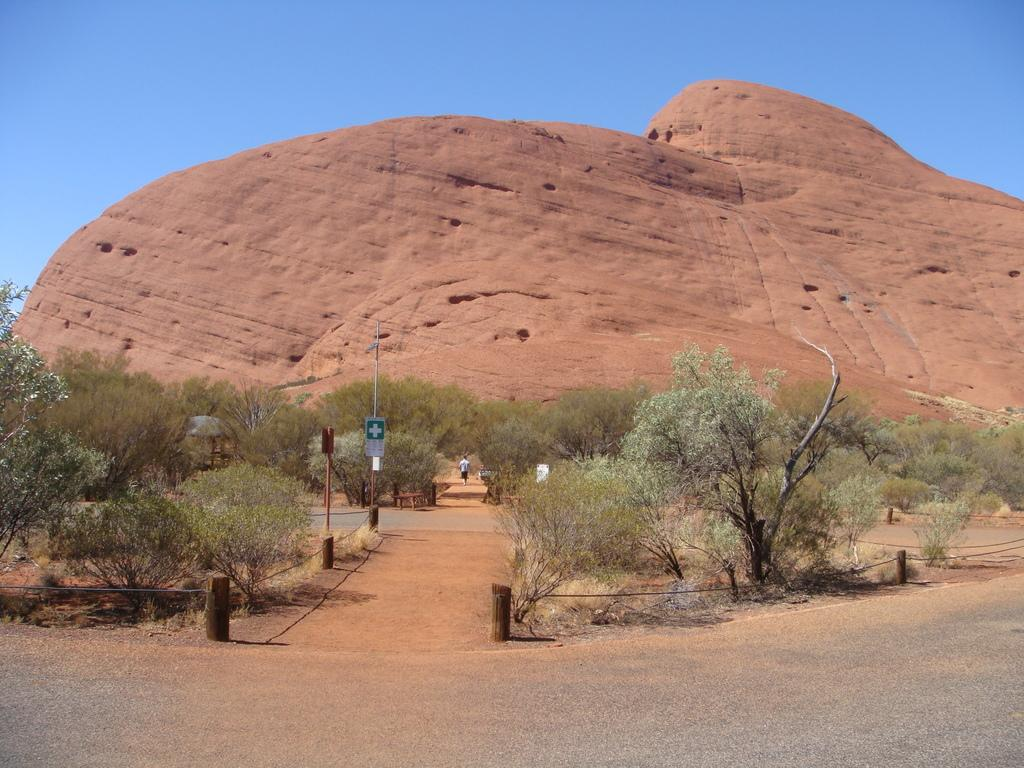What is the main feature in the center of the image? There is a mountain in the center of the image. What is located at the bottom of the image? There is a road at the bottom of the image. What type of vegetation can be seen in the image? Trees are present in the image. What else can be seen in the image besides the mountain, road, and trees? There is a pole in the image. What is visible in the background of the image? The sky is visible in the background of the image. What type of clover is growing on the mountain in the image? There is no clover visible in the image; the vegetation present is trees. What season is depicted in the image based on the apparel worn by the people? There are no people present in the image, so it is not possible to determine the season based on their apparel. 